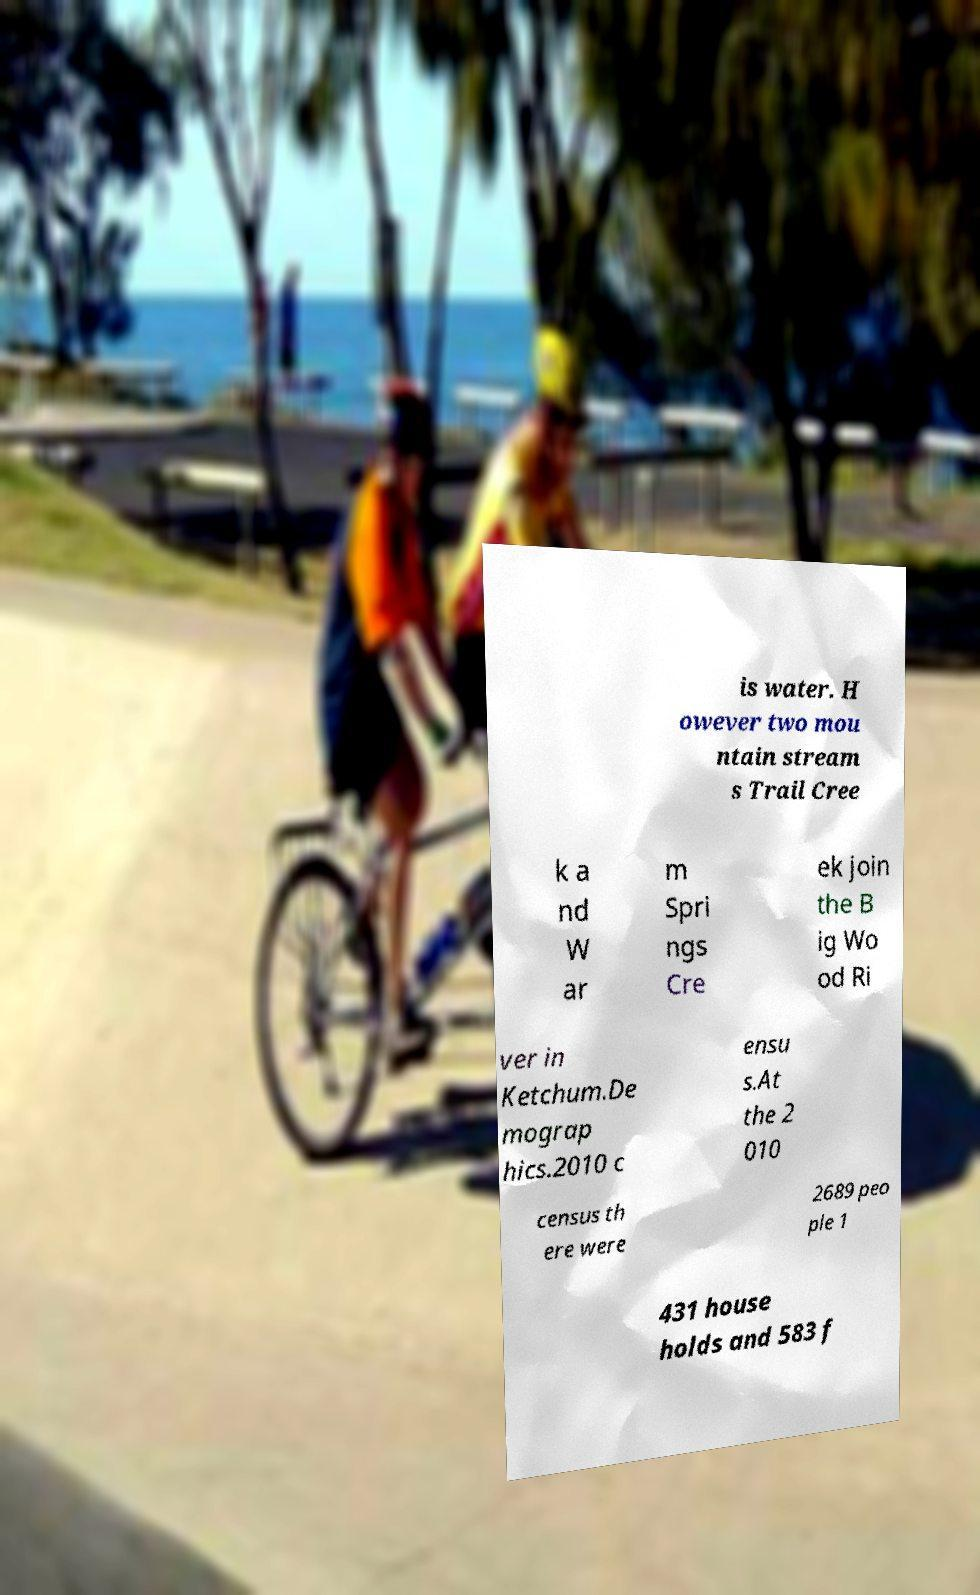Could you assist in decoding the text presented in this image and type it out clearly? is water. H owever two mou ntain stream s Trail Cree k a nd W ar m Spri ngs Cre ek join the B ig Wo od Ri ver in Ketchum.De mograp hics.2010 c ensu s.At the 2 010 census th ere were 2689 peo ple 1 431 house holds and 583 f 